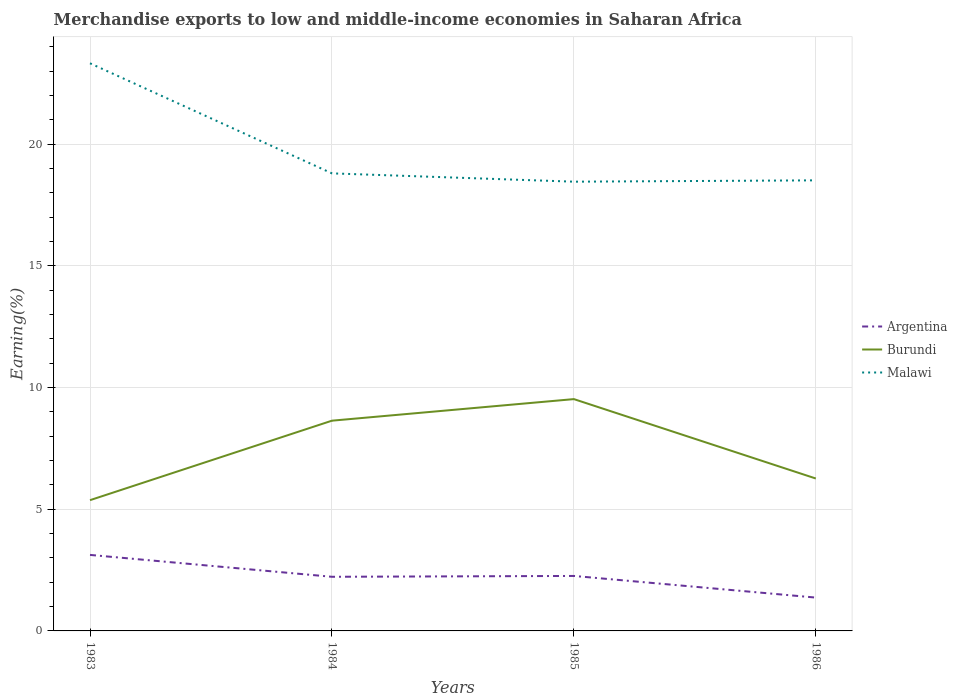Across all years, what is the maximum percentage of amount earned from merchandise exports in Argentina?
Provide a short and direct response. 1.37. What is the total percentage of amount earned from merchandise exports in Malawi in the graph?
Your answer should be very brief. 4.81. What is the difference between the highest and the second highest percentage of amount earned from merchandise exports in Malawi?
Your answer should be very brief. 4.86. Is the percentage of amount earned from merchandise exports in Argentina strictly greater than the percentage of amount earned from merchandise exports in Burundi over the years?
Give a very brief answer. Yes. How many lines are there?
Provide a succinct answer. 3. Does the graph contain any zero values?
Give a very brief answer. No. Where does the legend appear in the graph?
Your response must be concise. Center right. What is the title of the graph?
Provide a short and direct response. Merchandise exports to low and middle-income economies in Saharan Africa. Does "Burundi" appear as one of the legend labels in the graph?
Your answer should be very brief. Yes. What is the label or title of the X-axis?
Provide a succinct answer. Years. What is the label or title of the Y-axis?
Provide a succinct answer. Earning(%). What is the Earning(%) of Argentina in 1983?
Provide a succinct answer. 3.12. What is the Earning(%) of Burundi in 1983?
Your answer should be very brief. 5.37. What is the Earning(%) of Malawi in 1983?
Provide a short and direct response. 23.32. What is the Earning(%) of Argentina in 1984?
Keep it short and to the point. 2.22. What is the Earning(%) in Burundi in 1984?
Offer a very short reply. 8.64. What is the Earning(%) of Malawi in 1984?
Ensure brevity in your answer.  18.8. What is the Earning(%) in Argentina in 1985?
Your answer should be very brief. 2.26. What is the Earning(%) in Burundi in 1985?
Provide a succinct answer. 9.52. What is the Earning(%) of Malawi in 1985?
Provide a succinct answer. 18.45. What is the Earning(%) in Argentina in 1986?
Offer a very short reply. 1.37. What is the Earning(%) of Burundi in 1986?
Offer a terse response. 6.26. What is the Earning(%) in Malawi in 1986?
Provide a short and direct response. 18.51. Across all years, what is the maximum Earning(%) in Argentina?
Make the answer very short. 3.12. Across all years, what is the maximum Earning(%) in Burundi?
Your answer should be compact. 9.52. Across all years, what is the maximum Earning(%) of Malawi?
Your answer should be very brief. 23.32. Across all years, what is the minimum Earning(%) of Argentina?
Make the answer very short. 1.37. Across all years, what is the minimum Earning(%) in Burundi?
Keep it short and to the point. 5.37. Across all years, what is the minimum Earning(%) in Malawi?
Ensure brevity in your answer.  18.45. What is the total Earning(%) in Argentina in the graph?
Ensure brevity in your answer.  8.97. What is the total Earning(%) in Burundi in the graph?
Provide a short and direct response. 29.79. What is the total Earning(%) of Malawi in the graph?
Keep it short and to the point. 79.07. What is the difference between the Earning(%) of Argentina in 1983 and that in 1984?
Provide a short and direct response. 0.9. What is the difference between the Earning(%) of Burundi in 1983 and that in 1984?
Provide a short and direct response. -3.26. What is the difference between the Earning(%) of Malawi in 1983 and that in 1984?
Your answer should be compact. 4.52. What is the difference between the Earning(%) in Argentina in 1983 and that in 1985?
Ensure brevity in your answer.  0.86. What is the difference between the Earning(%) in Burundi in 1983 and that in 1985?
Offer a terse response. -4.15. What is the difference between the Earning(%) of Malawi in 1983 and that in 1985?
Ensure brevity in your answer.  4.86. What is the difference between the Earning(%) in Argentina in 1983 and that in 1986?
Make the answer very short. 1.75. What is the difference between the Earning(%) of Burundi in 1983 and that in 1986?
Your answer should be compact. -0.89. What is the difference between the Earning(%) in Malawi in 1983 and that in 1986?
Provide a short and direct response. 4.81. What is the difference between the Earning(%) of Argentina in 1984 and that in 1985?
Give a very brief answer. -0.03. What is the difference between the Earning(%) of Burundi in 1984 and that in 1985?
Give a very brief answer. -0.89. What is the difference between the Earning(%) in Malawi in 1984 and that in 1985?
Your answer should be compact. 0.34. What is the difference between the Earning(%) of Argentina in 1984 and that in 1986?
Give a very brief answer. 0.85. What is the difference between the Earning(%) of Burundi in 1984 and that in 1986?
Provide a short and direct response. 2.38. What is the difference between the Earning(%) in Malawi in 1984 and that in 1986?
Offer a terse response. 0.29. What is the difference between the Earning(%) in Argentina in 1985 and that in 1986?
Give a very brief answer. 0.89. What is the difference between the Earning(%) of Burundi in 1985 and that in 1986?
Keep it short and to the point. 3.26. What is the difference between the Earning(%) in Malawi in 1985 and that in 1986?
Keep it short and to the point. -0.05. What is the difference between the Earning(%) of Argentina in 1983 and the Earning(%) of Burundi in 1984?
Provide a succinct answer. -5.51. What is the difference between the Earning(%) in Argentina in 1983 and the Earning(%) in Malawi in 1984?
Provide a succinct answer. -15.67. What is the difference between the Earning(%) in Burundi in 1983 and the Earning(%) in Malawi in 1984?
Your answer should be very brief. -13.42. What is the difference between the Earning(%) of Argentina in 1983 and the Earning(%) of Burundi in 1985?
Offer a very short reply. -6.4. What is the difference between the Earning(%) in Argentina in 1983 and the Earning(%) in Malawi in 1985?
Give a very brief answer. -15.33. What is the difference between the Earning(%) of Burundi in 1983 and the Earning(%) of Malawi in 1985?
Provide a short and direct response. -13.08. What is the difference between the Earning(%) in Argentina in 1983 and the Earning(%) in Burundi in 1986?
Your answer should be compact. -3.14. What is the difference between the Earning(%) of Argentina in 1983 and the Earning(%) of Malawi in 1986?
Provide a short and direct response. -15.39. What is the difference between the Earning(%) in Burundi in 1983 and the Earning(%) in Malawi in 1986?
Your answer should be compact. -13.14. What is the difference between the Earning(%) in Argentina in 1984 and the Earning(%) in Burundi in 1985?
Give a very brief answer. -7.3. What is the difference between the Earning(%) of Argentina in 1984 and the Earning(%) of Malawi in 1985?
Offer a terse response. -16.23. What is the difference between the Earning(%) of Burundi in 1984 and the Earning(%) of Malawi in 1985?
Offer a very short reply. -9.82. What is the difference between the Earning(%) in Argentina in 1984 and the Earning(%) in Burundi in 1986?
Offer a terse response. -4.04. What is the difference between the Earning(%) in Argentina in 1984 and the Earning(%) in Malawi in 1986?
Provide a short and direct response. -16.28. What is the difference between the Earning(%) in Burundi in 1984 and the Earning(%) in Malawi in 1986?
Keep it short and to the point. -9.87. What is the difference between the Earning(%) in Argentina in 1985 and the Earning(%) in Burundi in 1986?
Offer a very short reply. -4. What is the difference between the Earning(%) of Argentina in 1985 and the Earning(%) of Malawi in 1986?
Provide a short and direct response. -16.25. What is the difference between the Earning(%) of Burundi in 1985 and the Earning(%) of Malawi in 1986?
Make the answer very short. -8.99. What is the average Earning(%) in Argentina per year?
Give a very brief answer. 2.24. What is the average Earning(%) of Burundi per year?
Your answer should be compact. 7.45. What is the average Earning(%) in Malawi per year?
Your response must be concise. 19.77. In the year 1983, what is the difference between the Earning(%) in Argentina and Earning(%) in Burundi?
Provide a short and direct response. -2.25. In the year 1983, what is the difference between the Earning(%) of Argentina and Earning(%) of Malawi?
Ensure brevity in your answer.  -20.19. In the year 1983, what is the difference between the Earning(%) of Burundi and Earning(%) of Malawi?
Offer a terse response. -17.95. In the year 1984, what is the difference between the Earning(%) in Argentina and Earning(%) in Burundi?
Offer a very short reply. -6.41. In the year 1984, what is the difference between the Earning(%) of Argentina and Earning(%) of Malawi?
Provide a succinct answer. -16.57. In the year 1984, what is the difference between the Earning(%) in Burundi and Earning(%) in Malawi?
Your answer should be compact. -10.16. In the year 1985, what is the difference between the Earning(%) of Argentina and Earning(%) of Burundi?
Offer a very short reply. -7.26. In the year 1985, what is the difference between the Earning(%) in Argentina and Earning(%) in Malawi?
Your answer should be compact. -16.2. In the year 1985, what is the difference between the Earning(%) in Burundi and Earning(%) in Malawi?
Your response must be concise. -8.93. In the year 1986, what is the difference between the Earning(%) in Argentina and Earning(%) in Burundi?
Offer a very short reply. -4.89. In the year 1986, what is the difference between the Earning(%) of Argentina and Earning(%) of Malawi?
Provide a short and direct response. -17.14. In the year 1986, what is the difference between the Earning(%) of Burundi and Earning(%) of Malawi?
Offer a terse response. -12.25. What is the ratio of the Earning(%) in Argentina in 1983 to that in 1984?
Provide a short and direct response. 1.4. What is the ratio of the Earning(%) of Burundi in 1983 to that in 1984?
Provide a short and direct response. 0.62. What is the ratio of the Earning(%) of Malawi in 1983 to that in 1984?
Make the answer very short. 1.24. What is the ratio of the Earning(%) of Argentina in 1983 to that in 1985?
Offer a very short reply. 1.38. What is the ratio of the Earning(%) of Burundi in 1983 to that in 1985?
Ensure brevity in your answer.  0.56. What is the ratio of the Earning(%) in Malawi in 1983 to that in 1985?
Your answer should be very brief. 1.26. What is the ratio of the Earning(%) of Argentina in 1983 to that in 1986?
Make the answer very short. 2.28. What is the ratio of the Earning(%) of Burundi in 1983 to that in 1986?
Your response must be concise. 0.86. What is the ratio of the Earning(%) of Malawi in 1983 to that in 1986?
Provide a short and direct response. 1.26. What is the ratio of the Earning(%) of Argentina in 1984 to that in 1985?
Offer a very short reply. 0.98. What is the ratio of the Earning(%) in Burundi in 1984 to that in 1985?
Offer a very short reply. 0.91. What is the ratio of the Earning(%) in Malawi in 1984 to that in 1985?
Keep it short and to the point. 1.02. What is the ratio of the Earning(%) in Argentina in 1984 to that in 1986?
Keep it short and to the point. 1.62. What is the ratio of the Earning(%) in Burundi in 1984 to that in 1986?
Keep it short and to the point. 1.38. What is the ratio of the Earning(%) of Malawi in 1984 to that in 1986?
Your answer should be compact. 1.02. What is the ratio of the Earning(%) of Argentina in 1985 to that in 1986?
Your response must be concise. 1.65. What is the ratio of the Earning(%) of Burundi in 1985 to that in 1986?
Your answer should be very brief. 1.52. What is the difference between the highest and the second highest Earning(%) in Argentina?
Offer a very short reply. 0.86. What is the difference between the highest and the second highest Earning(%) in Burundi?
Provide a succinct answer. 0.89. What is the difference between the highest and the second highest Earning(%) in Malawi?
Your answer should be very brief. 4.52. What is the difference between the highest and the lowest Earning(%) in Argentina?
Make the answer very short. 1.75. What is the difference between the highest and the lowest Earning(%) of Burundi?
Make the answer very short. 4.15. What is the difference between the highest and the lowest Earning(%) of Malawi?
Your response must be concise. 4.86. 